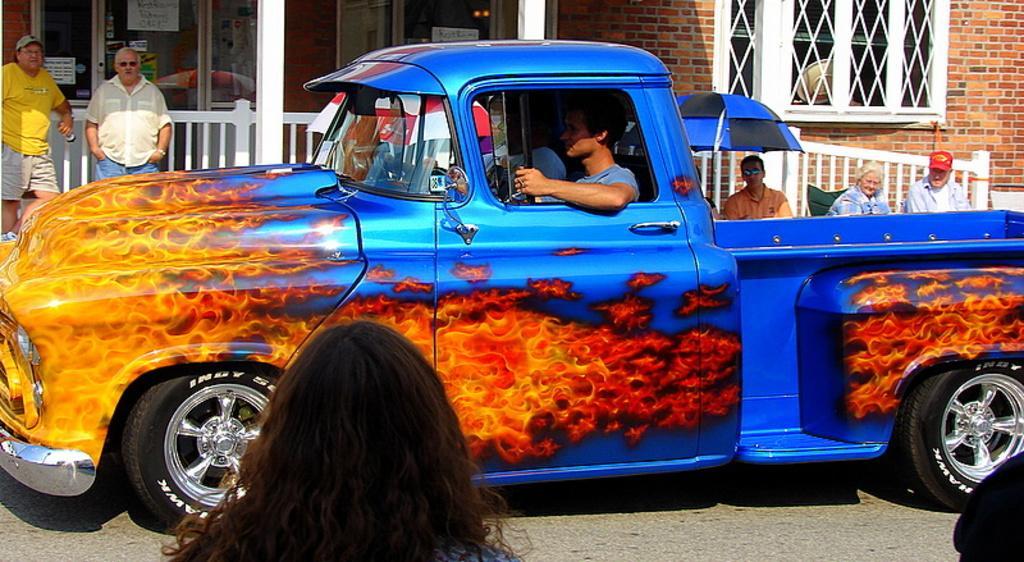How would you summarize this image in a sentence or two? In this image we can see a blue color car with fire painted on it. There is a man sitting inside the car. In the background of the image we can see a building, an umbrella, few persons and a glass window. 